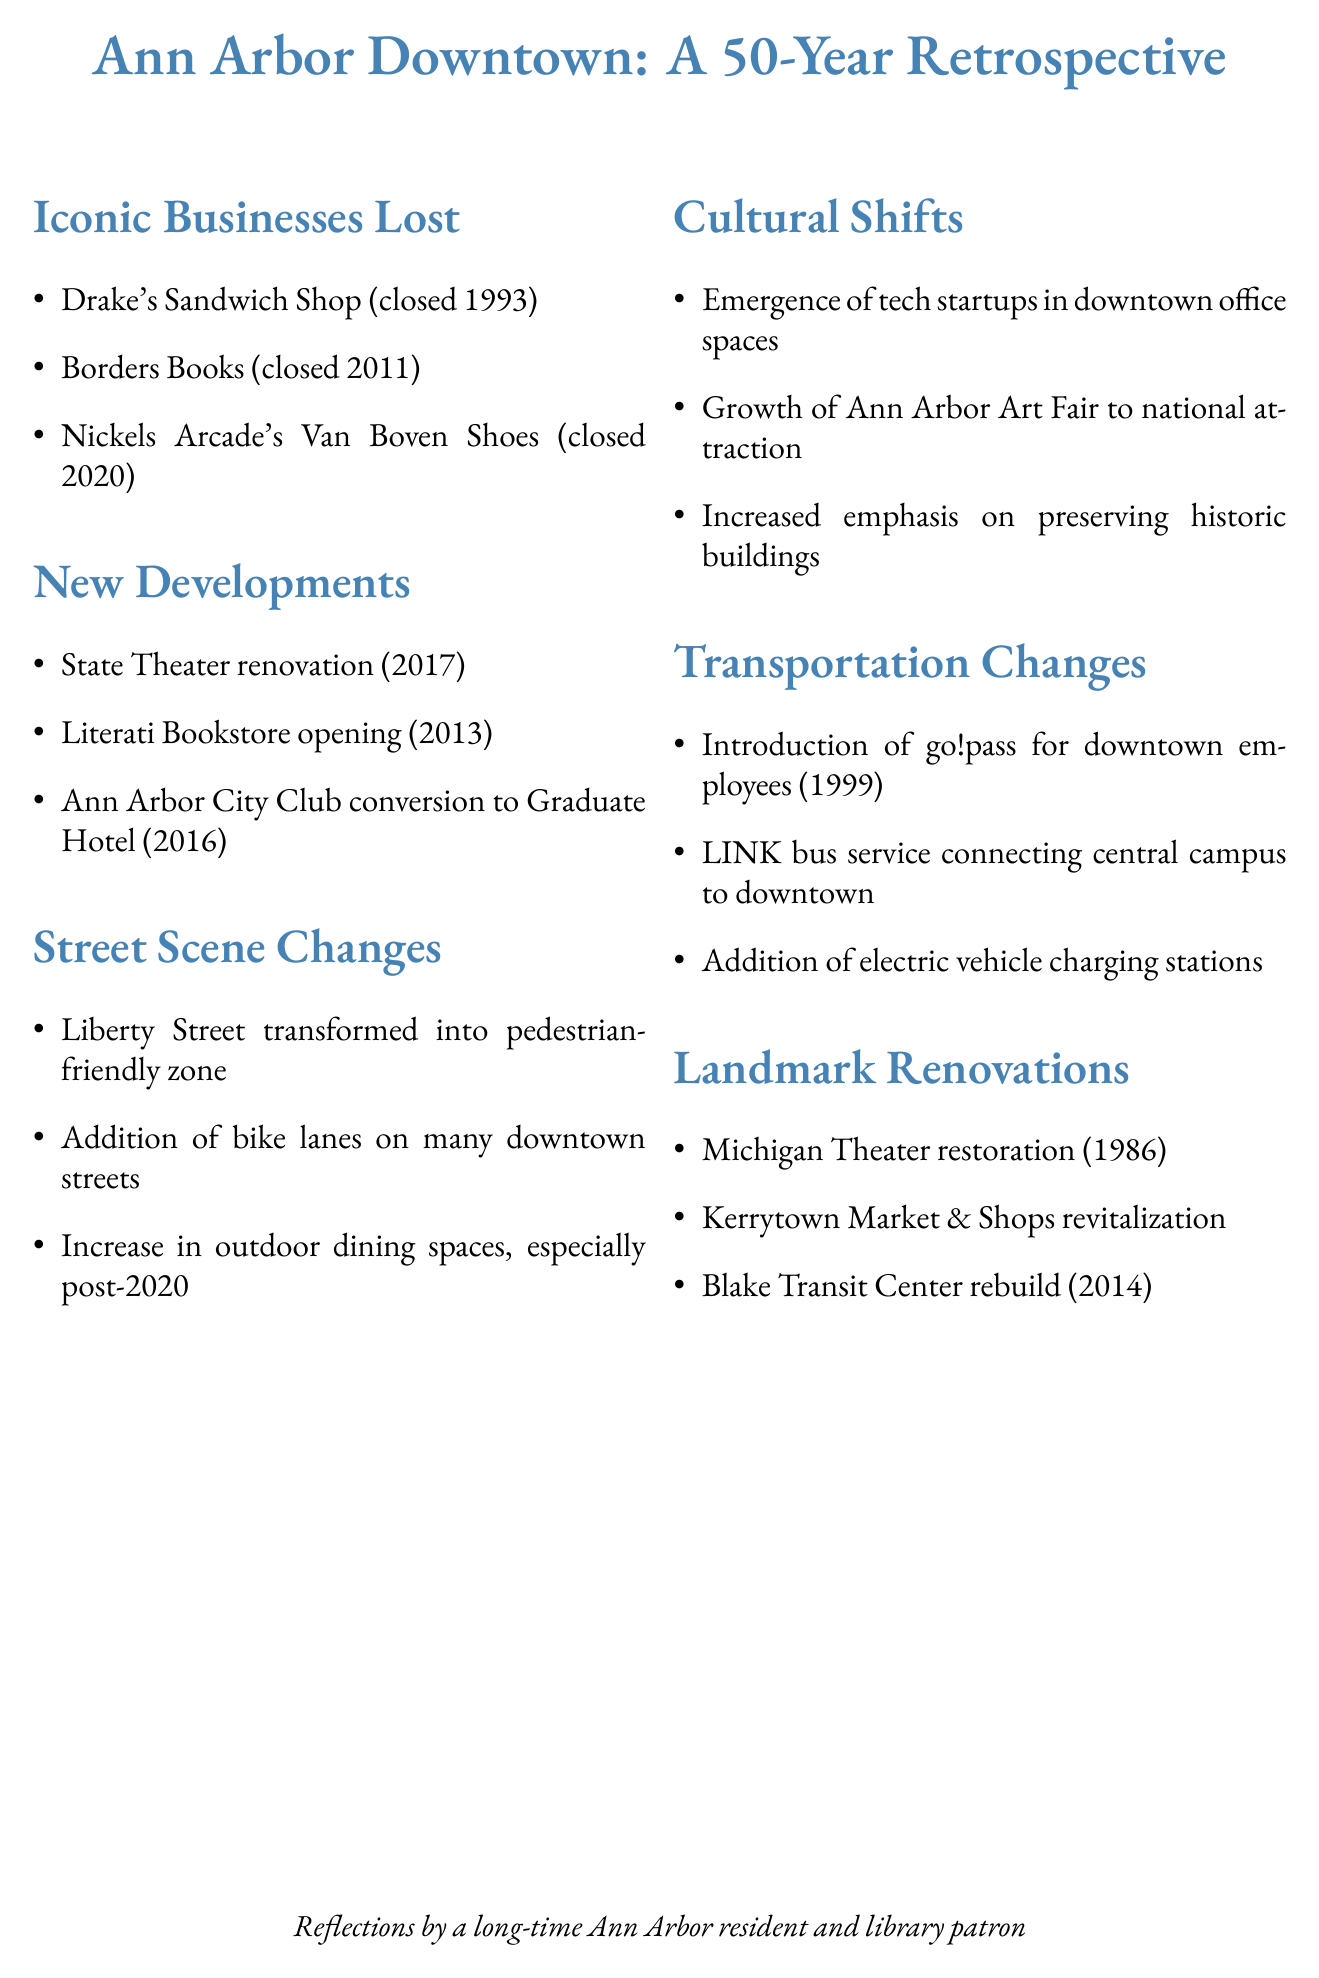What iconic business closed in 1993? Drake's Sandwich Shop is listed as an iconic business that was closed in 1993.
Answer: Drake's Sandwich Shop When did Borders Books close? The document states that Borders Books closed in 2011.
Answer: 2011 What significant transportation change was introduced in 1999? The go!pass for downtown employees was introduced in 1999, as mentioned in the transportation changes section.
Answer: go!pass Which landmark was restored in 1986? The Michigan Theater is noted for its restoration in 1986.
Answer: Michigan Theater What year did Literati Bookstore open? The document specifies that Literati Bookstore opened in 2013.
Answer: 2013 What is a recent outdoor change observed in downtown Ann Arbor? The increase in outdoor dining spaces, especially post-2020, is a noted change in the street scene.
Answer: Increase in outdoor dining spaces What cultural shift has occurred relating to tech? The emergence of tech startups in downtown office spaces signifies a cultural shift.
Answer: Emergence of tech startups What renovation took place at Kerrytown? The document states that Kerrytown Market & Shops underwent revitalization.
Answer: Revitalization What bus service connects central campus to downtown? The LINK bus service is mentioned as connecting central campus to downtown.
Answer: LINK bus service 